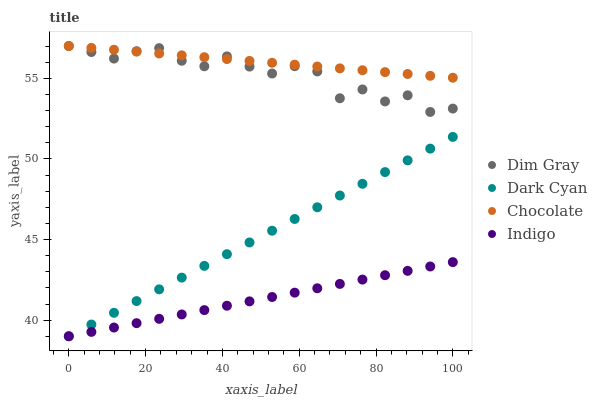Does Indigo have the minimum area under the curve?
Answer yes or no. Yes. Does Chocolate have the maximum area under the curve?
Answer yes or no. Yes. Does Dim Gray have the minimum area under the curve?
Answer yes or no. No. Does Dim Gray have the maximum area under the curve?
Answer yes or no. No. Is Chocolate the smoothest?
Answer yes or no. Yes. Is Dim Gray the roughest?
Answer yes or no. Yes. Is Indigo the smoothest?
Answer yes or no. No. Is Indigo the roughest?
Answer yes or no. No. Does Dark Cyan have the lowest value?
Answer yes or no. Yes. Does Dim Gray have the lowest value?
Answer yes or no. No. Does Chocolate have the highest value?
Answer yes or no. Yes. Does Indigo have the highest value?
Answer yes or no. No. Is Dark Cyan less than Dim Gray?
Answer yes or no. Yes. Is Dim Gray greater than Indigo?
Answer yes or no. Yes. Does Indigo intersect Dark Cyan?
Answer yes or no. Yes. Is Indigo less than Dark Cyan?
Answer yes or no. No. Is Indigo greater than Dark Cyan?
Answer yes or no. No. Does Dark Cyan intersect Dim Gray?
Answer yes or no. No. 